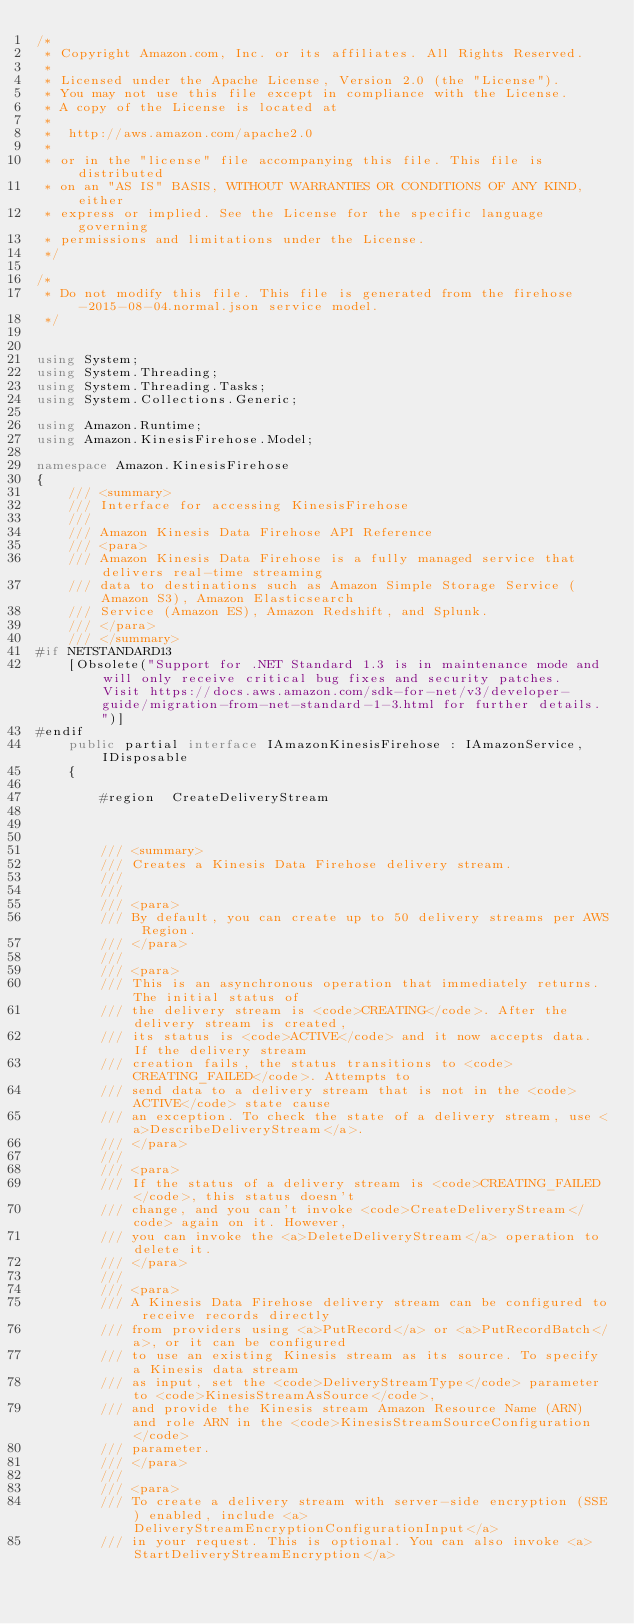<code> <loc_0><loc_0><loc_500><loc_500><_C#_>/*
 * Copyright Amazon.com, Inc. or its affiliates. All Rights Reserved.
 * 
 * Licensed under the Apache License, Version 2.0 (the "License").
 * You may not use this file except in compliance with the License.
 * A copy of the License is located at
 * 
 *  http://aws.amazon.com/apache2.0
 * 
 * or in the "license" file accompanying this file. This file is distributed
 * on an "AS IS" BASIS, WITHOUT WARRANTIES OR CONDITIONS OF ANY KIND, either
 * express or implied. See the License for the specific language governing
 * permissions and limitations under the License.
 */

/*
 * Do not modify this file. This file is generated from the firehose-2015-08-04.normal.json service model.
 */


using System;
using System.Threading;
using System.Threading.Tasks;
using System.Collections.Generic;

using Amazon.Runtime;
using Amazon.KinesisFirehose.Model;

namespace Amazon.KinesisFirehose
{
    /// <summary>
    /// Interface for accessing KinesisFirehose
    ///
    /// Amazon Kinesis Data Firehose API Reference 
    /// <para>
    /// Amazon Kinesis Data Firehose is a fully managed service that delivers real-time streaming
    /// data to destinations such as Amazon Simple Storage Service (Amazon S3), Amazon Elasticsearch
    /// Service (Amazon ES), Amazon Redshift, and Splunk.
    /// </para>
    /// </summary>
#if NETSTANDARD13
    [Obsolete("Support for .NET Standard 1.3 is in maintenance mode and will only receive critical bug fixes and security patches. Visit https://docs.aws.amazon.com/sdk-for-net/v3/developer-guide/migration-from-net-standard-1-3.html for further details.")]
#endif
    public partial interface IAmazonKinesisFirehose : IAmazonService, IDisposable
    {
                
        #region  CreateDeliveryStream



        /// <summary>
        /// Creates a Kinesis Data Firehose delivery stream.
        /// 
        ///  
        /// <para>
        /// By default, you can create up to 50 delivery streams per AWS Region.
        /// </para>
        ///  
        /// <para>
        /// This is an asynchronous operation that immediately returns. The initial status of
        /// the delivery stream is <code>CREATING</code>. After the delivery stream is created,
        /// its status is <code>ACTIVE</code> and it now accepts data. If the delivery stream
        /// creation fails, the status transitions to <code>CREATING_FAILED</code>. Attempts to
        /// send data to a delivery stream that is not in the <code>ACTIVE</code> state cause
        /// an exception. To check the state of a delivery stream, use <a>DescribeDeliveryStream</a>.
        /// </para>
        ///  
        /// <para>
        /// If the status of a delivery stream is <code>CREATING_FAILED</code>, this status doesn't
        /// change, and you can't invoke <code>CreateDeliveryStream</code> again on it. However,
        /// you can invoke the <a>DeleteDeliveryStream</a> operation to delete it.
        /// </para>
        ///  
        /// <para>
        /// A Kinesis Data Firehose delivery stream can be configured to receive records directly
        /// from providers using <a>PutRecord</a> or <a>PutRecordBatch</a>, or it can be configured
        /// to use an existing Kinesis stream as its source. To specify a Kinesis data stream
        /// as input, set the <code>DeliveryStreamType</code> parameter to <code>KinesisStreamAsSource</code>,
        /// and provide the Kinesis stream Amazon Resource Name (ARN) and role ARN in the <code>KinesisStreamSourceConfiguration</code>
        /// parameter.
        /// </para>
        ///  
        /// <para>
        /// To create a delivery stream with server-side encryption (SSE) enabled, include <a>DeliveryStreamEncryptionConfigurationInput</a>
        /// in your request. This is optional. You can also invoke <a>StartDeliveryStreamEncryption</a></code> 